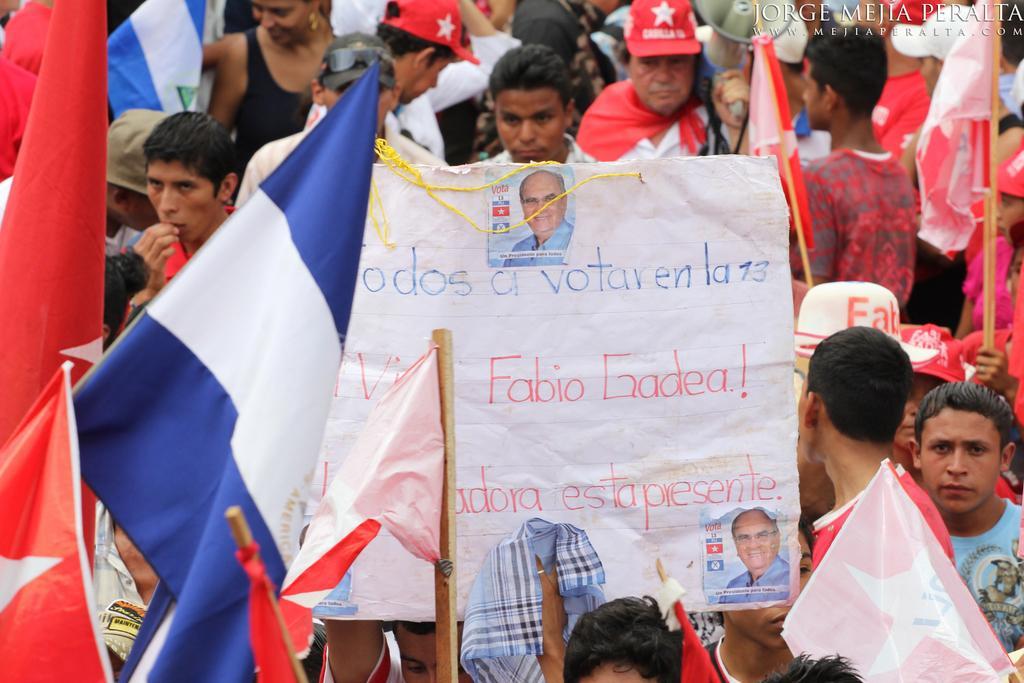Describe this image in one or two sentences. In this image I can see number of people are standing and in the front I can see one of them is holding a white colour board and on it I can see something is written. I can also see number of flags and on the top side of this image I can see a megaphone. On the top right side of this image I can see a watermark and on the bottom side I can see a cloth. 